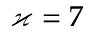Convert formula to latex. <formula><loc_0><loc_0><loc_500><loc_500>\varkappa = 7</formula> 